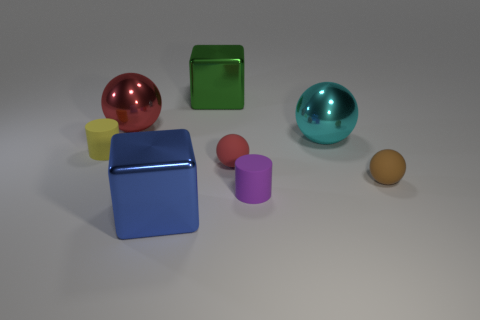Subtract all small red balls. How many balls are left? 3 Subtract all green cubes. How many red spheres are left? 2 Subtract all brown spheres. How many spheres are left? 3 Add 1 large objects. How many objects exist? 9 Subtract all green spheres. Subtract all green cubes. How many spheres are left? 4 Subtract all cylinders. How many objects are left? 6 Subtract all large gray cubes. Subtract all small matte cylinders. How many objects are left? 6 Add 5 shiny things. How many shiny things are left? 9 Add 6 big red shiny balls. How many big red shiny balls exist? 7 Subtract 0 cyan blocks. How many objects are left? 8 